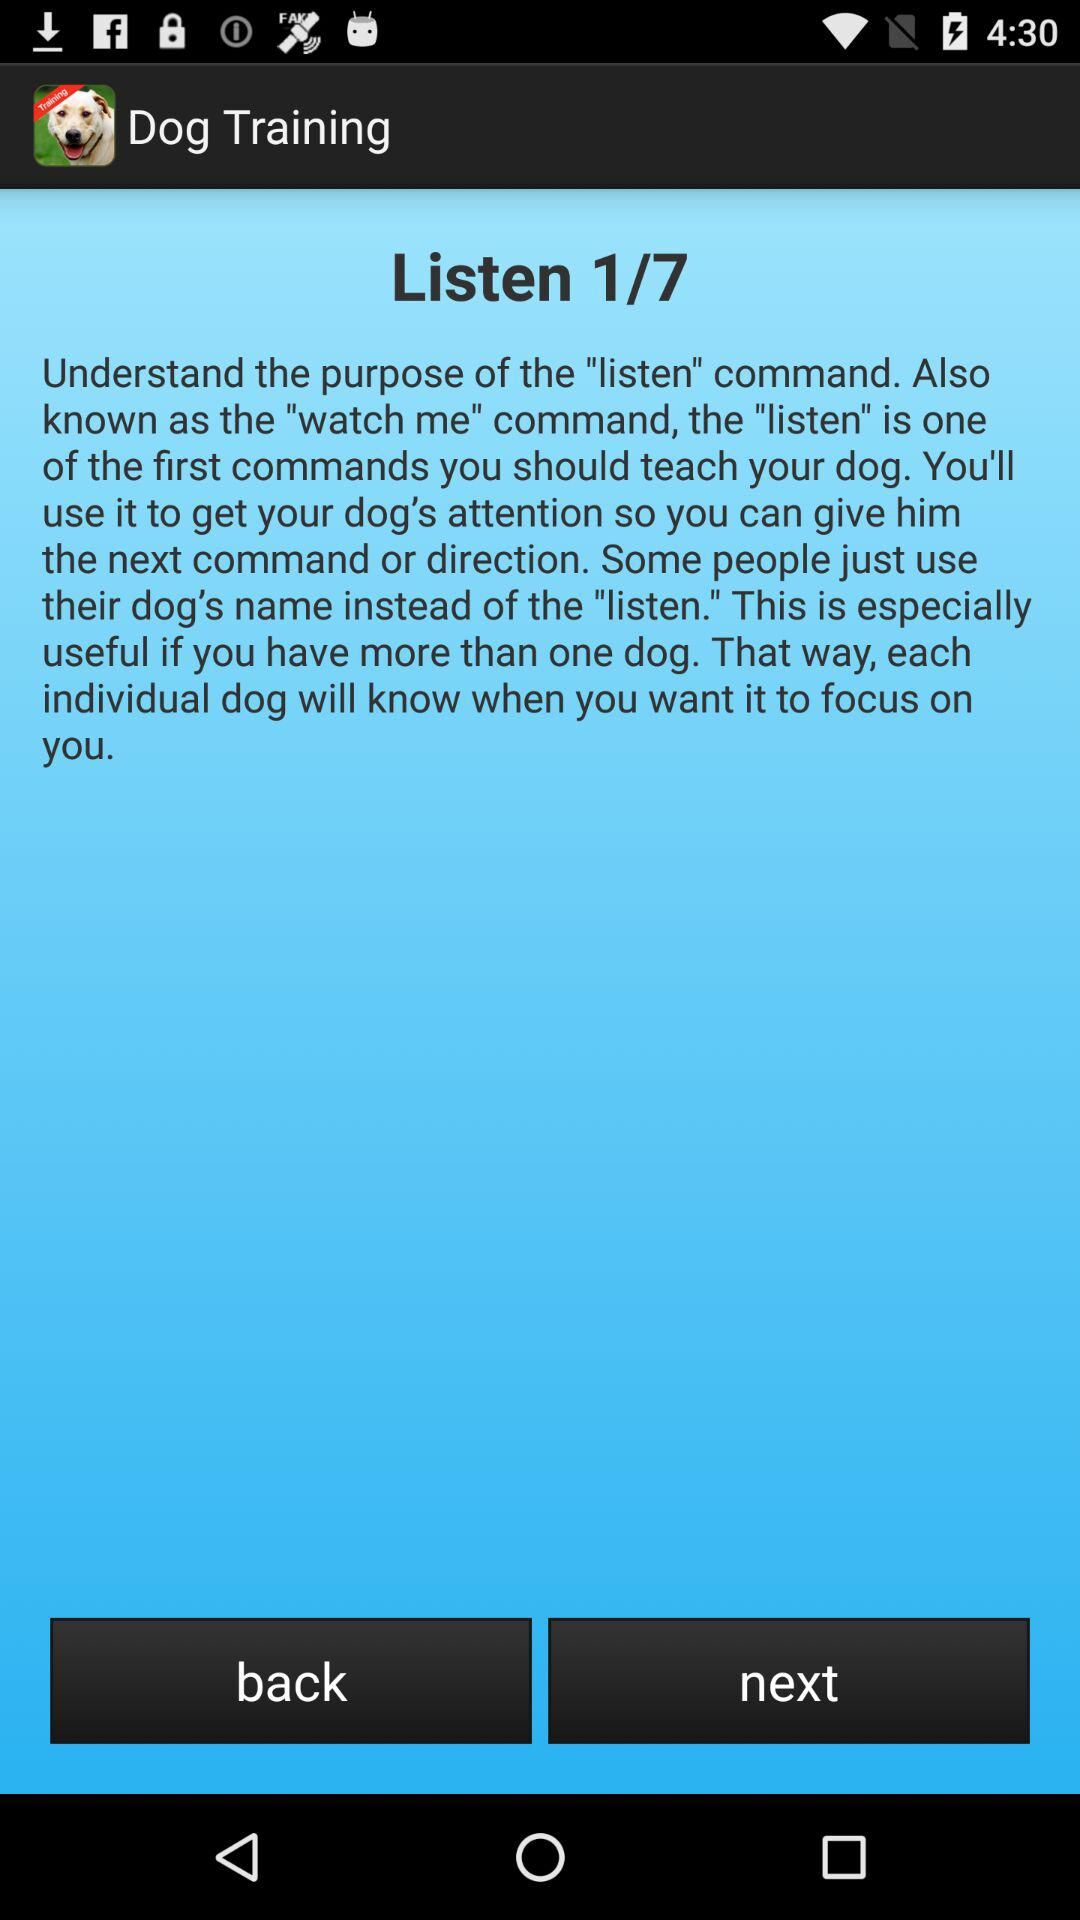How many steps are there in the dog training tutorial?
Answer the question using a single word or phrase. 7 